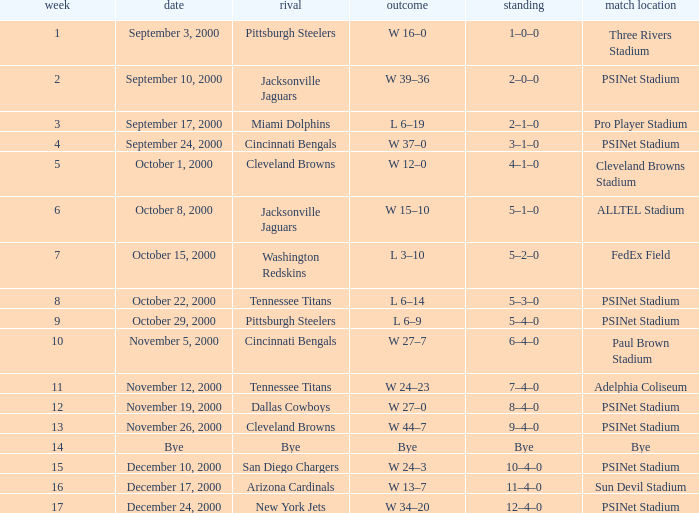What's the record after week 16? 12–4–0. 